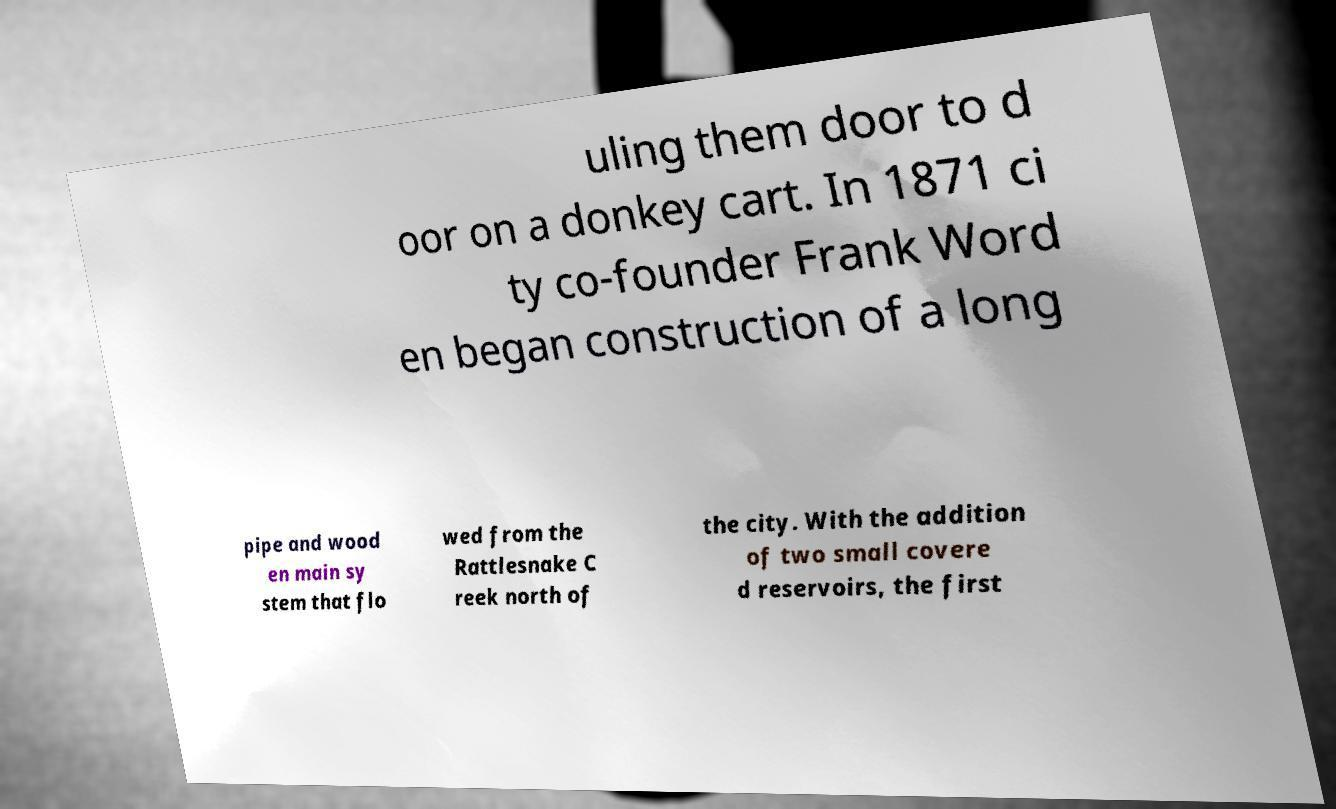Can you read and provide the text displayed in the image?This photo seems to have some interesting text. Can you extract and type it out for me? uling them door to d oor on a donkey cart. In 1871 ci ty co-founder Frank Word en began construction of a long pipe and wood en main sy stem that flo wed from the Rattlesnake C reek north of the city. With the addition of two small covere d reservoirs, the first 